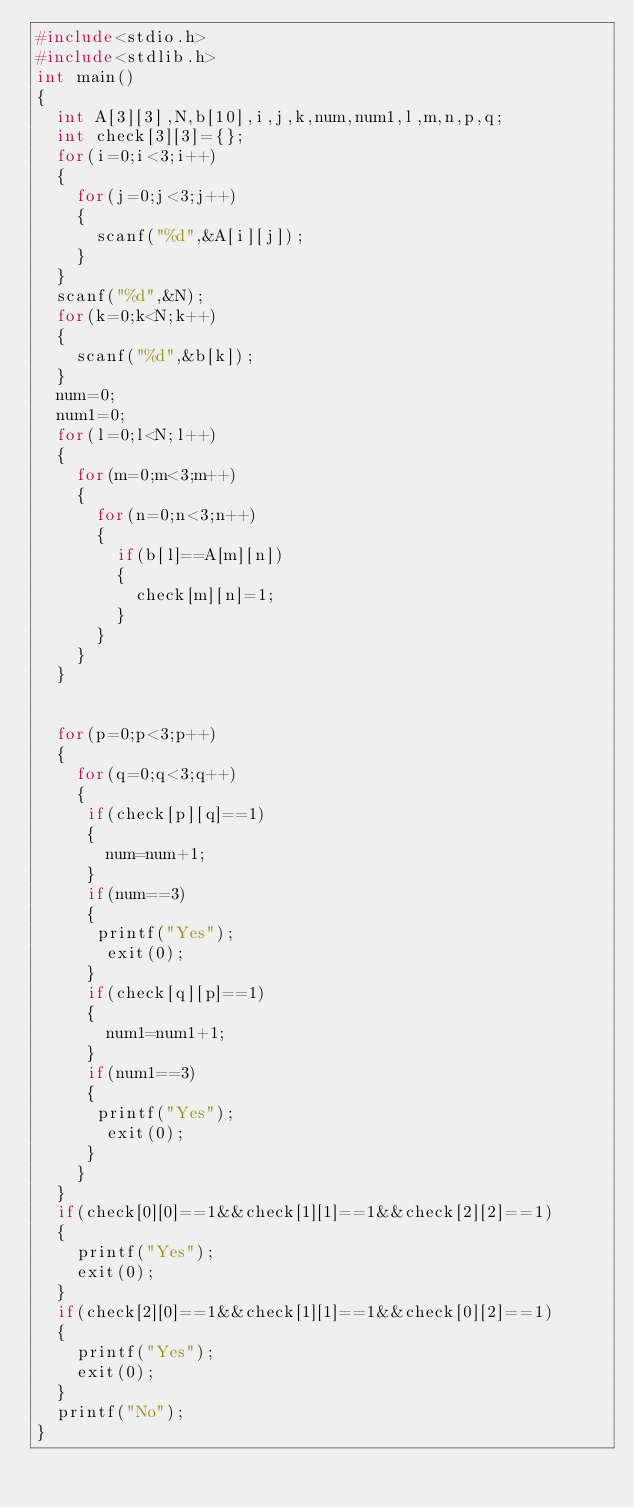Convert code to text. <code><loc_0><loc_0><loc_500><loc_500><_C_>#include<stdio.h>
#include<stdlib.h>
int main()
{
  int A[3][3],N,b[10],i,j,k,num,num1,l,m,n,p,q;
  int check[3][3]={};
  for(i=0;i<3;i++)
  {
    for(j=0;j<3;j++)
    {
      scanf("%d",&A[i][j]);
    }
  }
  scanf("%d",&N);
  for(k=0;k<N;k++)
  {
    scanf("%d",&b[k]);
  }
  num=0;
  num1=0;
  for(l=0;l<N;l++)
  {
    for(m=0;m<3;m++)
    {
      for(n=0;n<3;n++)
      {
        if(b[l]==A[m][n])
        {
          check[m][n]=1;
        }
      }
    }
  }
 
  
  for(p=0;p<3;p++)
  {
    for(q=0;q<3;q++)
    {
     if(check[p][q]==1)
     {
       num=num+1;
     }
     if(num==3)
     {
      printf("Yes");
       exit(0);
     }
     if(check[q][p]==1)
     {
       num1=num1+1;
     }
     if(num1==3)
     {
      printf("Yes");
       exit(0);
     }
    }
  }
  if(check[0][0]==1&&check[1][1]==1&&check[2][2]==1)
  {
    printf("Yes");
    exit(0);
  }
  if(check[2][0]==1&&check[1][1]==1&&check[0][2]==1)
  {
    printf("Yes");
    exit(0);
  }
  printf("No");
}
  
      
          
  
        
       
              
  </code> 